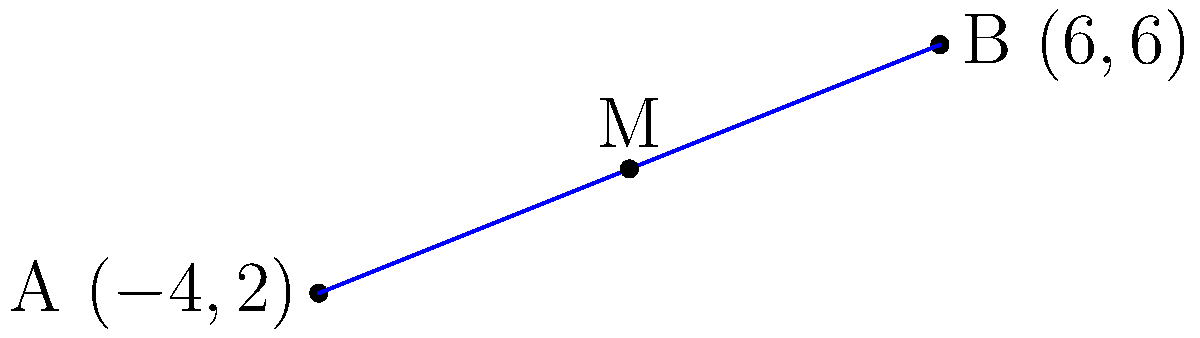Two high-end shopping districts are located at coordinates $A(-4,2)$ and $B(6,6)$ on a city map. To optimize customer service, you want to establish a midpoint location for a luxury concierge service. What are the coordinates of this midpoint $M$? To find the midpoint $M$ of a line segment connecting two points $A(x_1, y_1)$ and $B(x_2, y_2)$, we use the midpoint formula:

$$M = (\frac{x_1 + x_2}{2}, \frac{y_1 + y_2}{2})$$

Given:
$A(-4,2)$ and $B(6,6)$

Step 1: Calculate the x-coordinate of the midpoint:
$$x_M = \frac{x_1 + x_2}{2} = \frac{-4 + 6}{2} = \frac{2}{2} = 1$$

Step 2: Calculate the y-coordinate of the midpoint:
$$y_M = \frac{y_1 + y_2}{2} = \frac{2 + 6}{2} = \frac{8}{2} = 4$$

Therefore, the coordinates of the midpoint $M$ are $(1,4)$.
Answer: $(1,4)$ 